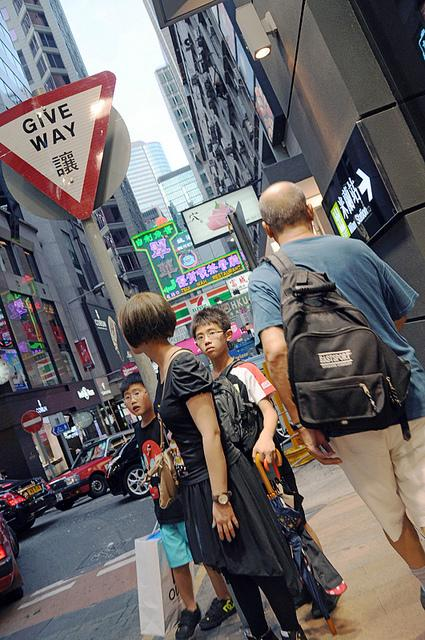The neon signs on the street are located in which city in Asia?

Choices:
A) beijing
B) hong kong
C) tokyo
D) taipei hong kong 